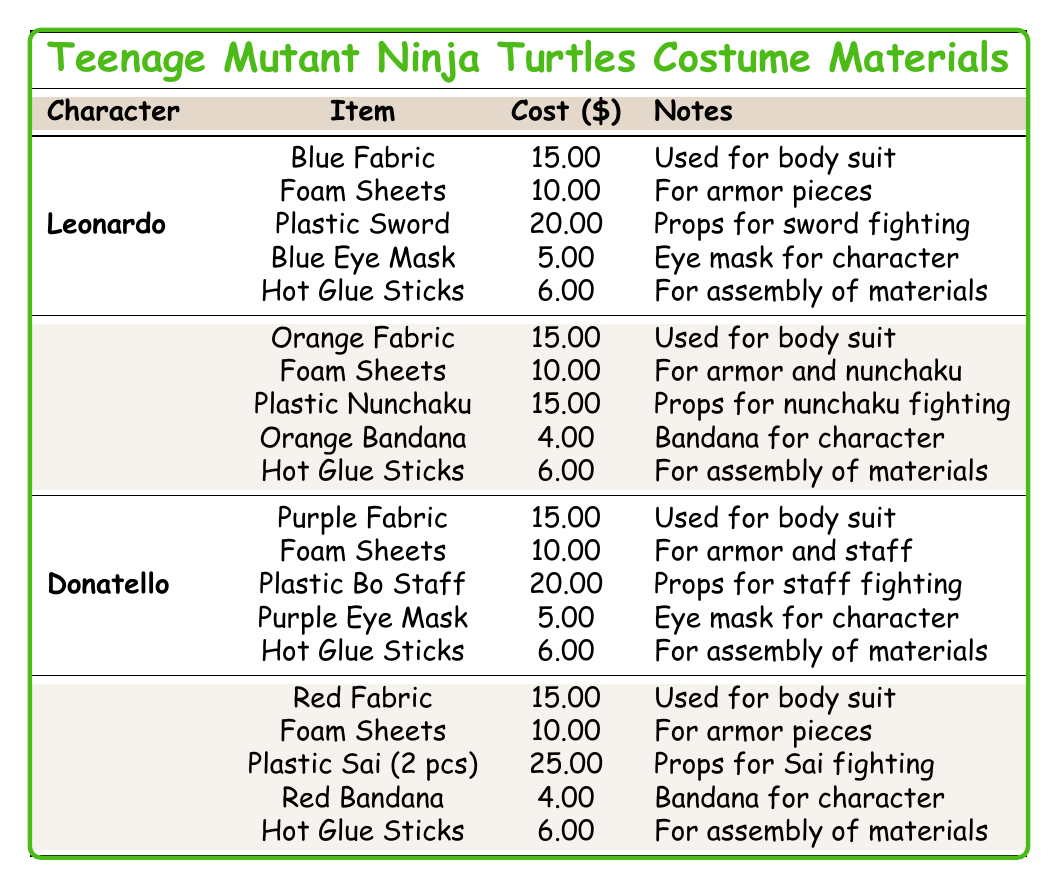What is the total cost of creating a costume for Raphael? The total cost for Raphael's costume is directly listed in the table, which shows a value of $60.
Answer: $60 How much does the Plastic Sword for Leonardo cost compared to the Plastic Sai for Raphael? The cost of the Plastic Sword is $20 and the cost of the Plastic Sai is $25. To compare, $25 (Sai) - $20 (Sword) = $5, so the Sai is $5 more expensive than the Sword.
Answer: $5 Which character has the lowest total costume cost? Looking at the total costs of all characters, Michelangelo is $50, while Leonardo and Donatello are $56, and Raphael is $60. Hence, Michelangelo has the lowest cost.
Answer: Michelangelo How many yards of fabric are needed for Donatello's costume? The table indicates that Donatello requires 3 yards of Purple Fabric for his costume.
Answer: 3 yards If you sum the costs of Hot Glue Sticks for all characters, what is the total? Each character requires 1 pack of Hot Glue Sticks costing $6. Since there are 4 characters, the total cost is 4 * $6 = $24.
Answer: $24 Which character's materials include Nunchaku? The table specifies that Michelangelo's materials include Plastic Nunchaku, while other characters have different items listed.
Answer: Michelangelo What is the average cost of the body suit fabric for all the characters? Each character's body suit fabric costs $15 (Blue, Orange, Purple, and Red). There are 4 characters, so the average cost is (15 + 15 + 15 + 15) / 4 = $15.
Answer: $15 Is the cost of Foam Sheets the same for all characters? The table shows that all characters, Leonardo, Michelangelo, Donatello, and Raphael, have the same cost of $10 for Foam Sheets, so yes, they are the same.
Answer: Yes Which character has the most expensive prop? By examining each character's listed prop costs, Raphael's Plastic Sai costs $25, which is higher than Leonardo's $20 Plastic Sword, Michelangelo's $15 Nunchaku, and Donatello's $20 Bo Staff.
Answer: Raphael How much more does it cost to create Raphael's costume compared to Michelangelo's costume? The total cost for Raphael is $60, and for Michelangelo, it is $50. Therefore, the cost difference is $60 - $50 = $10.
Answer: $10 If I only want to create costumes for Donatello and Leonardo, what will be the combined total cost? The total cost for Donatello is $56 and for Leonardo is $56. Adding these together gives $56 + $56 = $112.
Answer: $112 